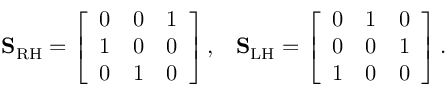Convert formula to latex. <formula><loc_0><loc_0><loc_500><loc_500>S _ { R H } = \left [ \begin{array} { l l l } { 0 } & { 0 } & { 1 } \\ { 1 } & { 0 } & { 0 } \\ { 0 } & { 1 } & { 0 } \end{array} \right ] , \, S _ { L H } = \left [ \begin{array} { l l l } { 0 } & { 1 } & { 0 } \\ { 0 } & { 0 } & { 1 } \\ { 1 } & { 0 } & { 0 } \end{array} \right ] .</formula> 